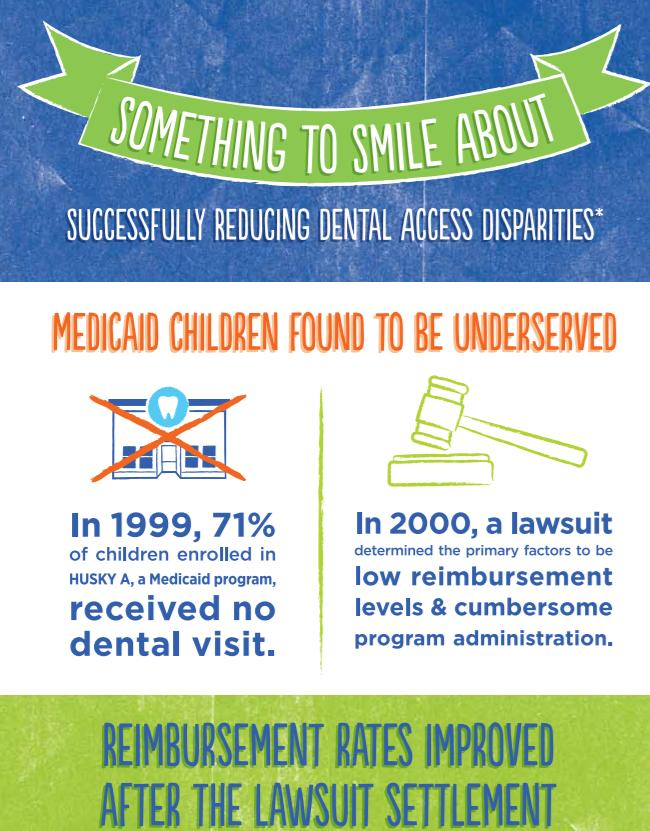Specify some key components in this picture. According to the given data, 29% of children received dental visits. 